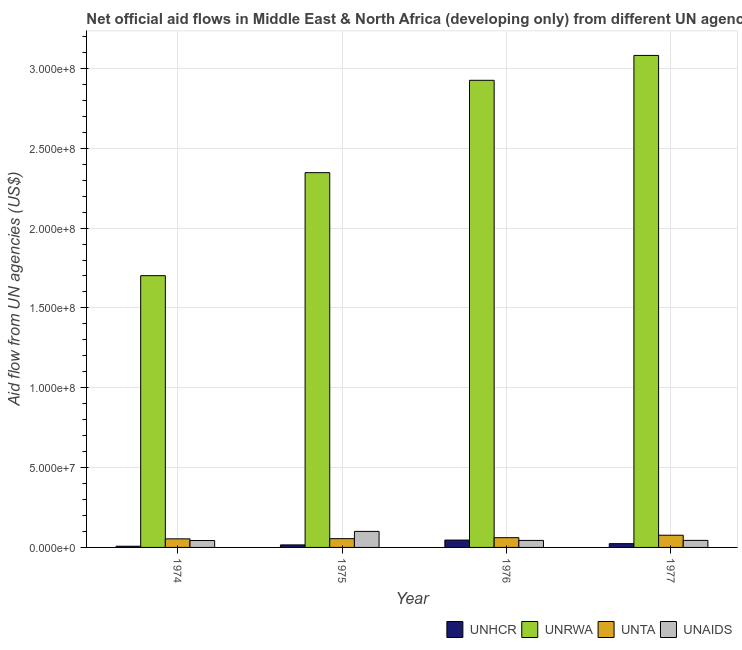Are the number of bars per tick equal to the number of legend labels?
Give a very brief answer. Yes. How many bars are there on the 1st tick from the left?
Offer a very short reply. 4. How many bars are there on the 2nd tick from the right?
Your answer should be very brief. 4. What is the label of the 3rd group of bars from the left?
Ensure brevity in your answer.  1976. In how many cases, is the number of bars for a given year not equal to the number of legend labels?
Your response must be concise. 0. What is the amount of aid given by unrwa in 1975?
Provide a short and direct response. 2.35e+08. Across all years, what is the maximum amount of aid given by unaids?
Ensure brevity in your answer.  1.00e+07. Across all years, what is the minimum amount of aid given by unta?
Your response must be concise. 5.37e+06. In which year was the amount of aid given by unrwa maximum?
Your answer should be very brief. 1977. In which year was the amount of aid given by unrwa minimum?
Provide a succinct answer. 1974. What is the total amount of aid given by unaids in the graph?
Offer a very short reply. 2.32e+07. What is the difference between the amount of aid given by unrwa in 1974 and that in 1976?
Offer a very short reply. -1.22e+08. What is the difference between the amount of aid given by unta in 1976 and the amount of aid given by unrwa in 1975?
Your answer should be compact. 6.10e+05. What is the average amount of aid given by unaids per year?
Ensure brevity in your answer.  5.79e+06. In how many years, is the amount of aid given by unta greater than 260000000 US$?
Provide a succinct answer. 0. What is the ratio of the amount of aid given by unta in 1974 to that in 1975?
Your answer should be compact. 0.98. What is the difference between the highest and the second highest amount of aid given by unhcr?
Give a very brief answer. 2.23e+06. What is the difference between the highest and the lowest amount of aid given by unaids?
Keep it short and to the point. 5.72e+06. In how many years, is the amount of aid given by unta greater than the average amount of aid given by unta taken over all years?
Make the answer very short. 1. Is the sum of the amount of aid given by unhcr in 1975 and 1977 greater than the maximum amount of aid given by unrwa across all years?
Provide a short and direct response. No. Is it the case that in every year, the sum of the amount of aid given by unta and amount of aid given by unaids is greater than the sum of amount of aid given by unrwa and amount of aid given by unhcr?
Offer a terse response. No. What does the 4th bar from the left in 1975 represents?
Give a very brief answer. UNAIDS. What does the 4th bar from the right in 1976 represents?
Offer a very short reply. UNHCR. Is it the case that in every year, the sum of the amount of aid given by unhcr and amount of aid given by unrwa is greater than the amount of aid given by unta?
Offer a very short reply. Yes. How many years are there in the graph?
Provide a succinct answer. 4. Are the values on the major ticks of Y-axis written in scientific E-notation?
Your answer should be very brief. Yes. Does the graph contain any zero values?
Provide a succinct answer. No. Does the graph contain grids?
Your response must be concise. Yes. Where does the legend appear in the graph?
Offer a very short reply. Bottom right. What is the title of the graph?
Ensure brevity in your answer.  Net official aid flows in Middle East & North Africa (developing only) from different UN agencies. Does "Iceland" appear as one of the legend labels in the graph?
Ensure brevity in your answer.  No. What is the label or title of the Y-axis?
Provide a succinct answer. Aid flow from UN agencies (US$). What is the Aid flow from UN agencies (US$) in UNHCR in 1974?
Offer a terse response. 7.50e+05. What is the Aid flow from UN agencies (US$) of UNRWA in 1974?
Provide a succinct answer. 1.70e+08. What is the Aid flow from UN agencies (US$) of UNTA in 1974?
Offer a terse response. 5.37e+06. What is the Aid flow from UN agencies (US$) of UNAIDS in 1974?
Your answer should be very brief. 4.32e+06. What is the Aid flow from UN agencies (US$) of UNHCR in 1975?
Your response must be concise. 1.58e+06. What is the Aid flow from UN agencies (US$) in UNRWA in 1975?
Offer a terse response. 2.35e+08. What is the Aid flow from UN agencies (US$) in UNTA in 1975?
Make the answer very short. 5.49e+06. What is the Aid flow from UN agencies (US$) of UNAIDS in 1975?
Offer a very short reply. 1.00e+07. What is the Aid flow from UN agencies (US$) of UNHCR in 1976?
Make the answer very short. 4.61e+06. What is the Aid flow from UN agencies (US$) of UNRWA in 1976?
Ensure brevity in your answer.  2.93e+08. What is the Aid flow from UN agencies (US$) of UNTA in 1976?
Offer a terse response. 6.10e+06. What is the Aid flow from UN agencies (US$) of UNAIDS in 1976?
Provide a short and direct response. 4.39e+06. What is the Aid flow from UN agencies (US$) of UNHCR in 1977?
Provide a succinct answer. 2.38e+06. What is the Aid flow from UN agencies (US$) of UNRWA in 1977?
Give a very brief answer. 3.08e+08. What is the Aid flow from UN agencies (US$) in UNTA in 1977?
Offer a terse response. 7.64e+06. What is the Aid flow from UN agencies (US$) of UNAIDS in 1977?
Offer a very short reply. 4.41e+06. Across all years, what is the maximum Aid flow from UN agencies (US$) of UNHCR?
Provide a succinct answer. 4.61e+06. Across all years, what is the maximum Aid flow from UN agencies (US$) in UNRWA?
Make the answer very short. 3.08e+08. Across all years, what is the maximum Aid flow from UN agencies (US$) of UNTA?
Make the answer very short. 7.64e+06. Across all years, what is the maximum Aid flow from UN agencies (US$) in UNAIDS?
Your answer should be very brief. 1.00e+07. Across all years, what is the minimum Aid flow from UN agencies (US$) in UNHCR?
Offer a terse response. 7.50e+05. Across all years, what is the minimum Aid flow from UN agencies (US$) in UNRWA?
Give a very brief answer. 1.70e+08. Across all years, what is the minimum Aid flow from UN agencies (US$) of UNTA?
Provide a short and direct response. 5.37e+06. Across all years, what is the minimum Aid flow from UN agencies (US$) in UNAIDS?
Offer a terse response. 4.32e+06. What is the total Aid flow from UN agencies (US$) in UNHCR in the graph?
Make the answer very short. 9.32e+06. What is the total Aid flow from UN agencies (US$) of UNRWA in the graph?
Your answer should be compact. 1.01e+09. What is the total Aid flow from UN agencies (US$) of UNTA in the graph?
Your answer should be very brief. 2.46e+07. What is the total Aid flow from UN agencies (US$) of UNAIDS in the graph?
Your response must be concise. 2.32e+07. What is the difference between the Aid flow from UN agencies (US$) in UNHCR in 1974 and that in 1975?
Offer a very short reply. -8.30e+05. What is the difference between the Aid flow from UN agencies (US$) of UNRWA in 1974 and that in 1975?
Keep it short and to the point. -6.45e+07. What is the difference between the Aid flow from UN agencies (US$) in UNTA in 1974 and that in 1975?
Your response must be concise. -1.20e+05. What is the difference between the Aid flow from UN agencies (US$) of UNAIDS in 1974 and that in 1975?
Your answer should be very brief. -5.72e+06. What is the difference between the Aid flow from UN agencies (US$) in UNHCR in 1974 and that in 1976?
Ensure brevity in your answer.  -3.86e+06. What is the difference between the Aid flow from UN agencies (US$) of UNRWA in 1974 and that in 1976?
Your response must be concise. -1.22e+08. What is the difference between the Aid flow from UN agencies (US$) of UNTA in 1974 and that in 1976?
Your answer should be very brief. -7.30e+05. What is the difference between the Aid flow from UN agencies (US$) in UNAIDS in 1974 and that in 1976?
Offer a very short reply. -7.00e+04. What is the difference between the Aid flow from UN agencies (US$) in UNHCR in 1974 and that in 1977?
Keep it short and to the point. -1.63e+06. What is the difference between the Aid flow from UN agencies (US$) in UNRWA in 1974 and that in 1977?
Offer a terse response. -1.38e+08. What is the difference between the Aid flow from UN agencies (US$) in UNTA in 1974 and that in 1977?
Keep it short and to the point. -2.27e+06. What is the difference between the Aid flow from UN agencies (US$) in UNHCR in 1975 and that in 1976?
Provide a succinct answer. -3.03e+06. What is the difference between the Aid flow from UN agencies (US$) of UNRWA in 1975 and that in 1976?
Your answer should be very brief. -5.78e+07. What is the difference between the Aid flow from UN agencies (US$) in UNTA in 1975 and that in 1976?
Keep it short and to the point. -6.10e+05. What is the difference between the Aid flow from UN agencies (US$) of UNAIDS in 1975 and that in 1976?
Your answer should be compact. 5.65e+06. What is the difference between the Aid flow from UN agencies (US$) of UNHCR in 1975 and that in 1977?
Your answer should be compact. -8.00e+05. What is the difference between the Aid flow from UN agencies (US$) of UNRWA in 1975 and that in 1977?
Keep it short and to the point. -7.34e+07. What is the difference between the Aid flow from UN agencies (US$) in UNTA in 1975 and that in 1977?
Provide a succinct answer. -2.15e+06. What is the difference between the Aid flow from UN agencies (US$) of UNAIDS in 1975 and that in 1977?
Make the answer very short. 5.63e+06. What is the difference between the Aid flow from UN agencies (US$) of UNHCR in 1976 and that in 1977?
Provide a succinct answer. 2.23e+06. What is the difference between the Aid flow from UN agencies (US$) in UNRWA in 1976 and that in 1977?
Provide a short and direct response. -1.56e+07. What is the difference between the Aid flow from UN agencies (US$) in UNTA in 1976 and that in 1977?
Ensure brevity in your answer.  -1.54e+06. What is the difference between the Aid flow from UN agencies (US$) in UNAIDS in 1976 and that in 1977?
Keep it short and to the point. -2.00e+04. What is the difference between the Aid flow from UN agencies (US$) in UNHCR in 1974 and the Aid flow from UN agencies (US$) in UNRWA in 1975?
Ensure brevity in your answer.  -2.34e+08. What is the difference between the Aid flow from UN agencies (US$) in UNHCR in 1974 and the Aid flow from UN agencies (US$) in UNTA in 1975?
Offer a very short reply. -4.74e+06. What is the difference between the Aid flow from UN agencies (US$) in UNHCR in 1974 and the Aid flow from UN agencies (US$) in UNAIDS in 1975?
Offer a very short reply. -9.29e+06. What is the difference between the Aid flow from UN agencies (US$) of UNRWA in 1974 and the Aid flow from UN agencies (US$) of UNTA in 1975?
Ensure brevity in your answer.  1.65e+08. What is the difference between the Aid flow from UN agencies (US$) in UNRWA in 1974 and the Aid flow from UN agencies (US$) in UNAIDS in 1975?
Keep it short and to the point. 1.60e+08. What is the difference between the Aid flow from UN agencies (US$) of UNTA in 1974 and the Aid flow from UN agencies (US$) of UNAIDS in 1975?
Your answer should be very brief. -4.67e+06. What is the difference between the Aid flow from UN agencies (US$) in UNHCR in 1974 and the Aid flow from UN agencies (US$) in UNRWA in 1976?
Provide a succinct answer. -2.92e+08. What is the difference between the Aid flow from UN agencies (US$) in UNHCR in 1974 and the Aid flow from UN agencies (US$) in UNTA in 1976?
Make the answer very short. -5.35e+06. What is the difference between the Aid flow from UN agencies (US$) of UNHCR in 1974 and the Aid flow from UN agencies (US$) of UNAIDS in 1976?
Make the answer very short. -3.64e+06. What is the difference between the Aid flow from UN agencies (US$) in UNRWA in 1974 and the Aid flow from UN agencies (US$) in UNTA in 1976?
Your answer should be very brief. 1.64e+08. What is the difference between the Aid flow from UN agencies (US$) in UNRWA in 1974 and the Aid flow from UN agencies (US$) in UNAIDS in 1976?
Give a very brief answer. 1.66e+08. What is the difference between the Aid flow from UN agencies (US$) in UNTA in 1974 and the Aid flow from UN agencies (US$) in UNAIDS in 1976?
Your response must be concise. 9.80e+05. What is the difference between the Aid flow from UN agencies (US$) in UNHCR in 1974 and the Aid flow from UN agencies (US$) in UNRWA in 1977?
Offer a terse response. -3.07e+08. What is the difference between the Aid flow from UN agencies (US$) of UNHCR in 1974 and the Aid flow from UN agencies (US$) of UNTA in 1977?
Offer a very short reply. -6.89e+06. What is the difference between the Aid flow from UN agencies (US$) in UNHCR in 1974 and the Aid flow from UN agencies (US$) in UNAIDS in 1977?
Make the answer very short. -3.66e+06. What is the difference between the Aid flow from UN agencies (US$) in UNRWA in 1974 and the Aid flow from UN agencies (US$) in UNTA in 1977?
Ensure brevity in your answer.  1.63e+08. What is the difference between the Aid flow from UN agencies (US$) of UNRWA in 1974 and the Aid flow from UN agencies (US$) of UNAIDS in 1977?
Provide a short and direct response. 1.66e+08. What is the difference between the Aid flow from UN agencies (US$) in UNTA in 1974 and the Aid flow from UN agencies (US$) in UNAIDS in 1977?
Your answer should be very brief. 9.60e+05. What is the difference between the Aid flow from UN agencies (US$) of UNHCR in 1975 and the Aid flow from UN agencies (US$) of UNRWA in 1976?
Your answer should be very brief. -2.91e+08. What is the difference between the Aid flow from UN agencies (US$) of UNHCR in 1975 and the Aid flow from UN agencies (US$) of UNTA in 1976?
Offer a very short reply. -4.52e+06. What is the difference between the Aid flow from UN agencies (US$) in UNHCR in 1975 and the Aid flow from UN agencies (US$) in UNAIDS in 1976?
Offer a very short reply. -2.81e+06. What is the difference between the Aid flow from UN agencies (US$) of UNRWA in 1975 and the Aid flow from UN agencies (US$) of UNTA in 1976?
Provide a succinct answer. 2.29e+08. What is the difference between the Aid flow from UN agencies (US$) of UNRWA in 1975 and the Aid flow from UN agencies (US$) of UNAIDS in 1976?
Give a very brief answer. 2.30e+08. What is the difference between the Aid flow from UN agencies (US$) of UNTA in 1975 and the Aid flow from UN agencies (US$) of UNAIDS in 1976?
Your response must be concise. 1.10e+06. What is the difference between the Aid flow from UN agencies (US$) in UNHCR in 1975 and the Aid flow from UN agencies (US$) in UNRWA in 1977?
Provide a succinct answer. -3.07e+08. What is the difference between the Aid flow from UN agencies (US$) of UNHCR in 1975 and the Aid flow from UN agencies (US$) of UNTA in 1977?
Offer a terse response. -6.06e+06. What is the difference between the Aid flow from UN agencies (US$) in UNHCR in 1975 and the Aid flow from UN agencies (US$) in UNAIDS in 1977?
Offer a very short reply. -2.83e+06. What is the difference between the Aid flow from UN agencies (US$) in UNRWA in 1975 and the Aid flow from UN agencies (US$) in UNTA in 1977?
Keep it short and to the point. 2.27e+08. What is the difference between the Aid flow from UN agencies (US$) in UNRWA in 1975 and the Aid flow from UN agencies (US$) in UNAIDS in 1977?
Give a very brief answer. 2.30e+08. What is the difference between the Aid flow from UN agencies (US$) of UNTA in 1975 and the Aid flow from UN agencies (US$) of UNAIDS in 1977?
Keep it short and to the point. 1.08e+06. What is the difference between the Aid flow from UN agencies (US$) in UNHCR in 1976 and the Aid flow from UN agencies (US$) in UNRWA in 1977?
Keep it short and to the point. -3.04e+08. What is the difference between the Aid flow from UN agencies (US$) of UNHCR in 1976 and the Aid flow from UN agencies (US$) of UNTA in 1977?
Offer a very short reply. -3.03e+06. What is the difference between the Aid flow from UN agencies (US$) of UNRWA in 1976 and the Aid flow from UN agencies (US$) of UNTA in 1977?
Offer a terse response. 2.85e+08. What is the difference between the Aid flow from UN agencies (US$) in UNRWA in 1976 and the Aid flow from UN agencies (US$) in UNAIDS in 1977?
Make the answer very short. 2.88e+08. What is the difference between the Aid flow from UN agencies (US$) of UNTA in 1976 and the Aid flow from UN agencies (US$) of UNAIDS in 1977?
Keep it short and to the point. 1.69e+06. What is the average Aid flow from UN agencies (US$) of UNHCR per year?
Your answer should be compact. 2.33e+06. What is the average Aid flow from UN agencies (US$) in UNRWA per year?
Your answer should be compact. 2.51e+08. What is the average Aid flow from UN agencies (US$) of UNTA per year?
Give a very brief answer. 6.15e+06. What is the average Aid flow from UN agencies (US$) in UNAIDS per year?
Your response must be concise. 5.79e+06. In the year 1974, what is the difference between the Aid flow from UN agencies (US$) in UNHCR and Aid flow from UN agencies (US$) in UNRWA?
Your answer should be very brief. -1.69e+08. In the year 1974, what is the difference between the Aid flow from UN agencies (US$) in UNHCR and Aid flow from UN agencies (US$) in UNTA?
Offer a terse response. -4.62e+06. In the year 1974, what is the difference between the Aid flow from UN agencies (US$) of UNHCR and Aid flow from UN agencies (US$) of UNAIDS?
Offer a terse response. -3.57e+06. In the year 1974, what is the difference between the Aid flow from UN agencies (US$) of UNRWA and Aid flow from UN agencies (US$) of UNTA?
Make the answer very short. 1.65e+08. In the year 1974, what is the difference between the Aid flow from UN agencies (US$) of UNRWA and Aid flow from UN agencies (US$) of UNAIDS?
Provide a short and direct response. 1.66e+08. In the year 1974, what is the difference between the Aid flow from UN agencies (US$) in UNTA and Aid flow from UN agencies (US$) in UNAIDS?
Offer a terse response. 1.05e+06. In the year 1975, what is the difference between the Aid flow from UN agencies (US$) of UNHCR and Aid flow from UN agencies (US$) of UNRWA?
Your answer should be very brief. -2.33e+08. In the year 1975, what is the difference between the Aid flow from UN agencies (US$) in UNHCR and Aid flow from UN agencies (US$) in UNTA?
Make the answer very short. -3.91e+06. In the year 1975, what is the difference between the Aid flow from UN agencies (US$) of UNHCR and Aid flow from UN agencies (US$) of UNAIDS?
Provide a short and direct response. -8.46e+06. In the year 1975, what is the difference between the Aid flow from UN agencies (US$) in UNRWA and Aid flow from UN agencies (US$) in UNTA?
Give a very brief answer. 2.29e+08. In the year 1975, what is the difference between the Aid flow from UN agencies (US$) of UNRWA and Aid flow from UN agencies (US$) of UNAIDS?
Offer a terse response. 2.25e+08. In the year 1975, what is the difference between the Aid flow from UN agencies (US$) in UNTA and Aid flow from UN agencies (US$) in UNAIDS?
Your response must be concise. -4.55e+06. In the year 1976, what is the difference between the Aid flow from UN agencies (US$) in UNHCR and Aid flow from UN agencies (US$) in UNRWA?
Make the answer very short. -2.88e+08. In the year 1976, what is the difference between the Aid flow from UN agencies (US$) of UNHCR and Aid flow from UN agencies (US$) of UNTA?
Offer a very short reply. -1.49e+06. In the year 1976, what is the difference between the Aid flow from UN agencies (US$) of UNRWA and Aid flow from UN agencies (US$) of UNTA?
Provide a short and direct response. 2.86e+08. In the year 1976, what is the difference between the Aid flow from UN agencies (US$) of UNRWA and Aid flow from UN agencies (US$) of UNAIDS?
Keep it short and to the point. 2.88e+08. In the year 1976, what is the difference between the Aid flow from UN agencies (US$) of UNTA and Aid flow from UN agencies (US$) of UNAIDS?
Your response must be concise. 1.71e+06. In the year 1977, what is the difference between the Aid flow from UN agencies (US$) in UNHCR and Aid flow from UN agencies (US$) in UNRWA?
Your answer should be very brief. -3.06e+08. In the year 1977, what is the difference between the Aid flow from UN agencies (US$) in UNHCR and Aid flow from UN agencies (US$) in UNTA?
Your answer should be very brief. -5.26e+06. In the year 1977, what is the difference between the Aid flow from UN agencies (US$) of UNHCR and Aid flow from UN agencies (US$) of UNAIDS?
Make the answer very short. -2.03e+06. In the year 1977, what is the difference between the Aid flow from UN agencies (US$) of UNRWA and Aid flow from UN agencies (US$) of UNTA?
Keep it short and to the point. 3.00e+08. In the year 1977, what is the difference between the Aid flow from UN agencies (US$) of UNRWA and Aid flow from UN agencies (US$) of UNAIDS?
Give a very brief answer. 3.04e+08. In the year 1977, what is the difference between the Aid flow from UN agencies (US$) in UNTA and Aid flow from UN agencies (US$) in UNAIDS?
Offer a very short reply. 3.23e+06. What is the ratio of the Aid flow from UN agencies (US$) in UNHCR in 1974 to that in 1975?
Your answer should be very brief. 0.47. What is the ratio of the Aid flow from UN agencies (US$) in UNRWA in 1974 to that in 1975?
Provide a short and direct response. 0.73. What is the ratio of the Aid flow from UN agencies (US$) of UNTA in 1974 to that in 1975?
Give a very brief answer. 0.98. What is the ratio of the Aid flow from UN agencies (US$) of UNAIDS in 1974 to that in 1975?
Your answer should be compact. 0.43. What is the ratio of the Aid flow from UN agencies (US$) in UNHCR in 1974 to that in 1976?
Your answer should be very brief. 0.16. What is the ratio of the Aid flow from UN agencies (US$) of UNRWA in 1974 to that in 1976?
Offer a terse response. 0.58. What is the ratio of the Aid flow from UN agencies (US$) of UNTA in 1974 to that in 1976?
Ensure brevity in your answer.  0.88. What is the ratio of the Aid flow from UN agencies (US$) in UNAIDS in 1974 to that in 1976?
Your answer should be compact. 0.98. What is the ratio of the Aid flow from UN agencies (US$) of UNHCR in 1974 to that in 1977?
Your response must be concise. 0.32. What is the ratio of the Aid flow from UN agencies (US$) in UNRWA in 1974 to that in 1977?
Offer a very short reply. 0.55. What is the ratio of the Aid flow from UN agencies (US$) in UNTA in 1974 to that in 1977?
Provide a succinct answer. 0.7. What is the ratio of the Aid flow from UN agencies (US$) of UNAIDS in 1974 to that in 1977?
Provide a short and direct response. 0.98. What is the ratio of the Aid flow from UN agencies (US$) in UNHCR in 1975 to that in 1976?
Ensure brevity in your answer.  0.34. What is the ratio of the Aid flow from UN agencies (US$) in UNRWA in 1975 to that in 1976?
Offer a very short reply. 0.8. What is the ratio of the Aid flow from UN agencies (US$) in UNAIDS in 1975 to that in 1976?
Make the answer very short. 2.29. What is the ratio of the Aid flow from UN agencies (US$) in UNHCR in 1975 to that in 1977?
Ensure brevity in your answer.  0.66. What is the ratio of the Aid flow from UN agencies (US$) of UNRWA in 1975 to that in 1977?
Make the answer very short. 0.76. What is the ratio of the Aid flow from UN agencies (US$) in UNTA in 1975 to that in 1977?
Make the answer very short. 0.72. What is the ratio of the Aid flow from UN agencies (US$) in UNAIDS in 1975 to that in 1977?
Provide a short and direct response. 2.28. What is the ratio of the Aid flow from UN agencies (US$) in UNHCR in 1976 to that in 1977?
Your answer should be very brief. 1.94. What is the ratio of the Aid flow from UN agencies (US$) in UNRWA in 1976 to that in 1977?
Make the answer very short. 0.95. What is the ratio of the Aid flow from UN agencies (US$) in UNTA in 1976 to that in 1977?
Make the answer very short. 0.8. What is the difference between the highest and the second highest Aid flow from UN agencies (US$) of UNHCR?
Your answer should be very brief. 2.23e+06. What is the difference between the highest and the second highest Aid flow from UN agencies (US$) in UNRWA?
Provide a short and direct response. 1.56e+07. What is the difference between the highest and the second highest Aid flow from UN agencies (US$) of UNTA?
Provide a short and direct response. 1.54e+06. What is the difference between the highest and the second highest Aid flow from UN agencies (US$) in UNAIDS?
Ensure brevity in your answer.  5.63e+06. What is the difference between the highest and the lowest Aid flow from UN agencies (US$) in UNHCR?
Give a very brief answer. 3.86e+06. What is the difference between the highest and the lowest Aid flow from UN agencies (US$) in UNRWA?
Make the answer very short. 1.38e+08. What is the difference between the highest and the lowest Aid flow from UN agencies (US$) of UNTA?
Make the answer very short. 2.27e+06. What is the difference between the highest and the lowest Aid flow from UN agencies (US$) in UNAIDS?
Offer a very short reply. 5.72e+06. 